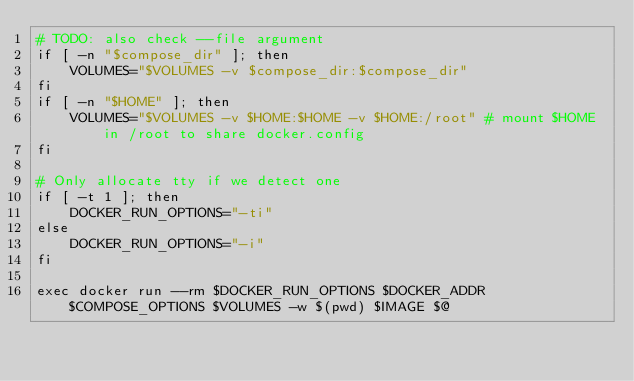Convert code to text. <code><loc_0><loc_0><loc_500><loc_500><_Bash_># TODO: also check --file argument
if [ -n "$compose_dir" ]; then
    VOLUMES="$VOLUMES -v $compose_dir:$compose_dir"
fi
if [ -n "$HOME" ]; then
    VOLUMES="$VOLUMES -v $HOME:$HOME -v $HOME:/root" # mount $HOME in /root to share docker.config
fi

# Only allocate tty if we detect one
if [ -t 1 ]; then
    DOCKER_RUN_OPTIONS="-ti"
else
    DOCKER_RUN_OPTIONS="-i"
fi

exec docker run --rm $DOCKER_RUN_OPTIONS $DOCKER_ADDR $COMPOSE_OPTIONS $VOLUMES -w $(pwd) $IMAGE $@
</code> 